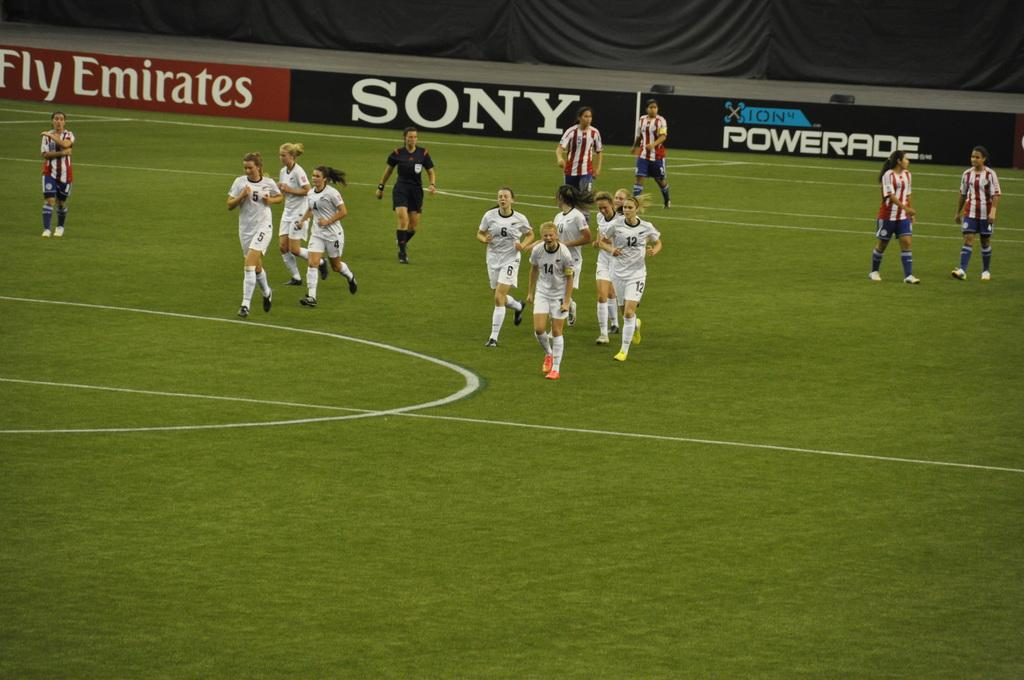What is the surface that the people are standing on in the image? The ground is covered with grass. What can be seen in the background of the image? There is a banner fencing visible in the background. What type of organization is responsible for the camera in the image? There is no camera present in the image, so it is not possible to determine which organization might be responsible for it. 